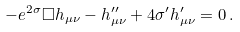<formula> <loc_0><loc_0><loc_500><loc_500>- e ^ { 2 \sigma } \Box h _ { \mu \nu } - h _ { \mu \nu } ^ { \prime \prime } + 4 \sigma ^ { \prime } h _ { \mu \nu } ^ { \prime } = 0 \, .</formula> 